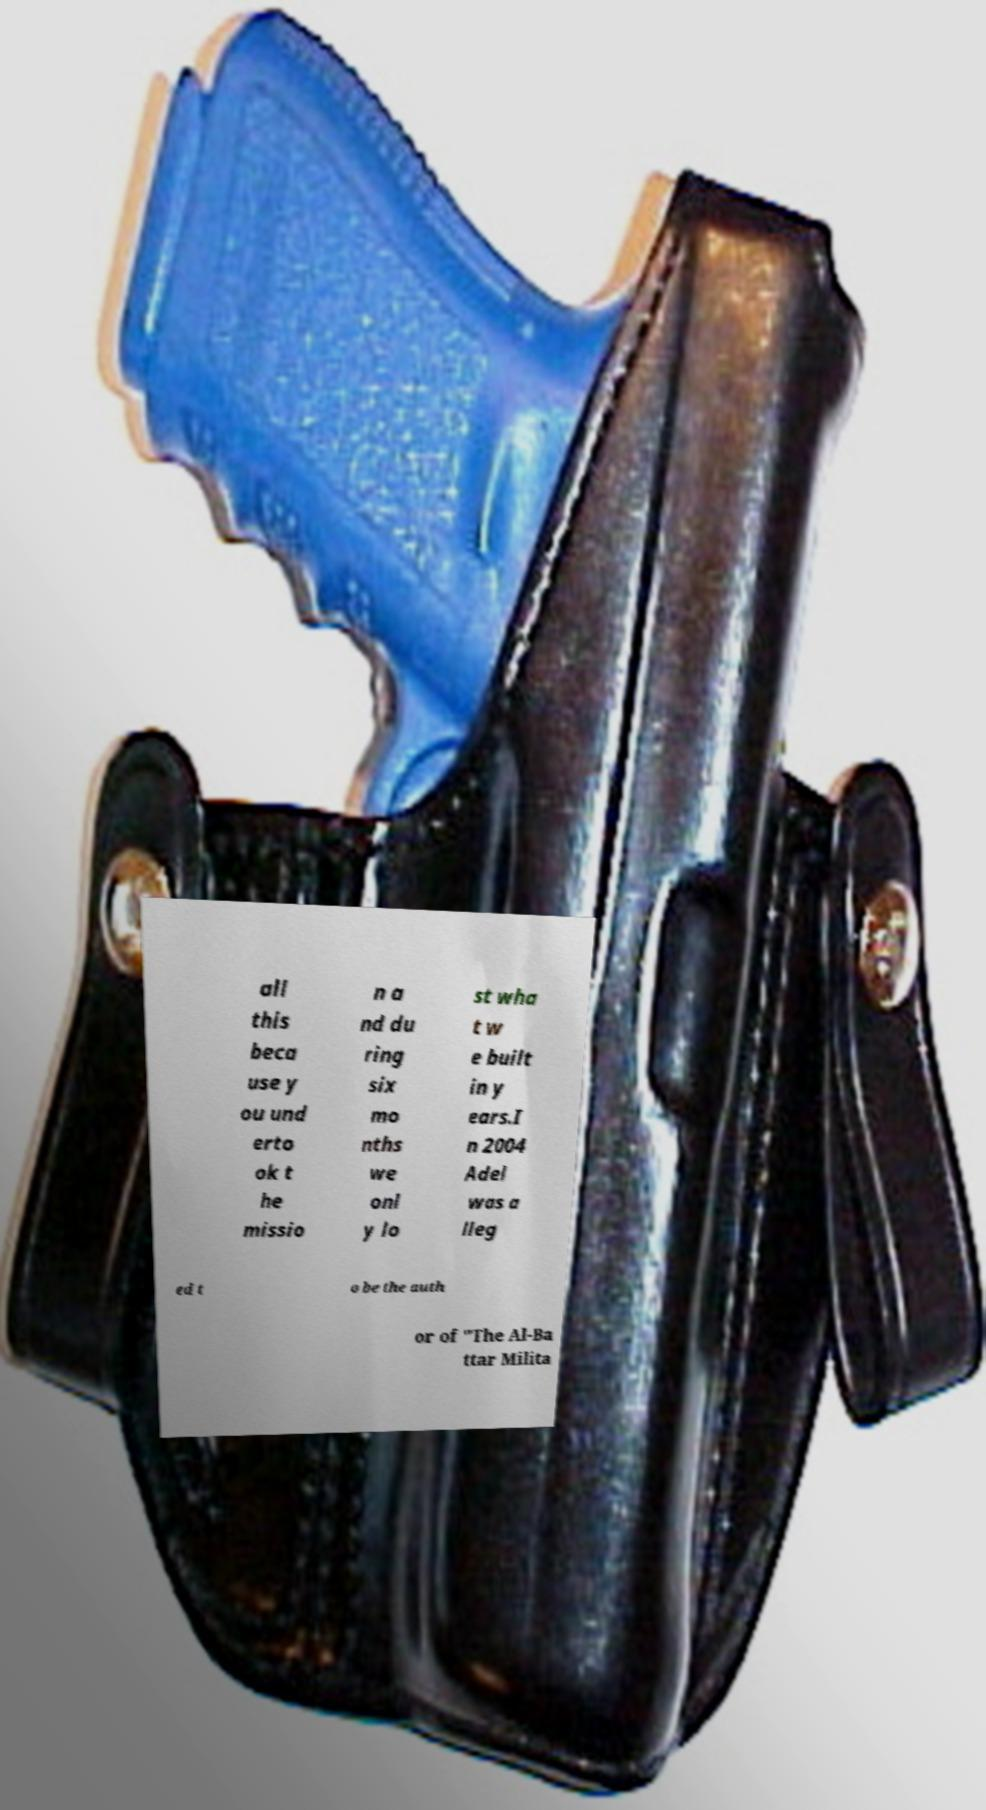Can you read and provide the text displayed in the image?This photo seems to have some interesting text. Can you extract and type it out for me? all this beca use y ou und erto ok t he missio n a nd du ring six mo nths we onl y lo st wha t w e built in y ears.I n 2004 Adel was a lleg ed t o be the auth or of "The Al-Ba ttar Milita 